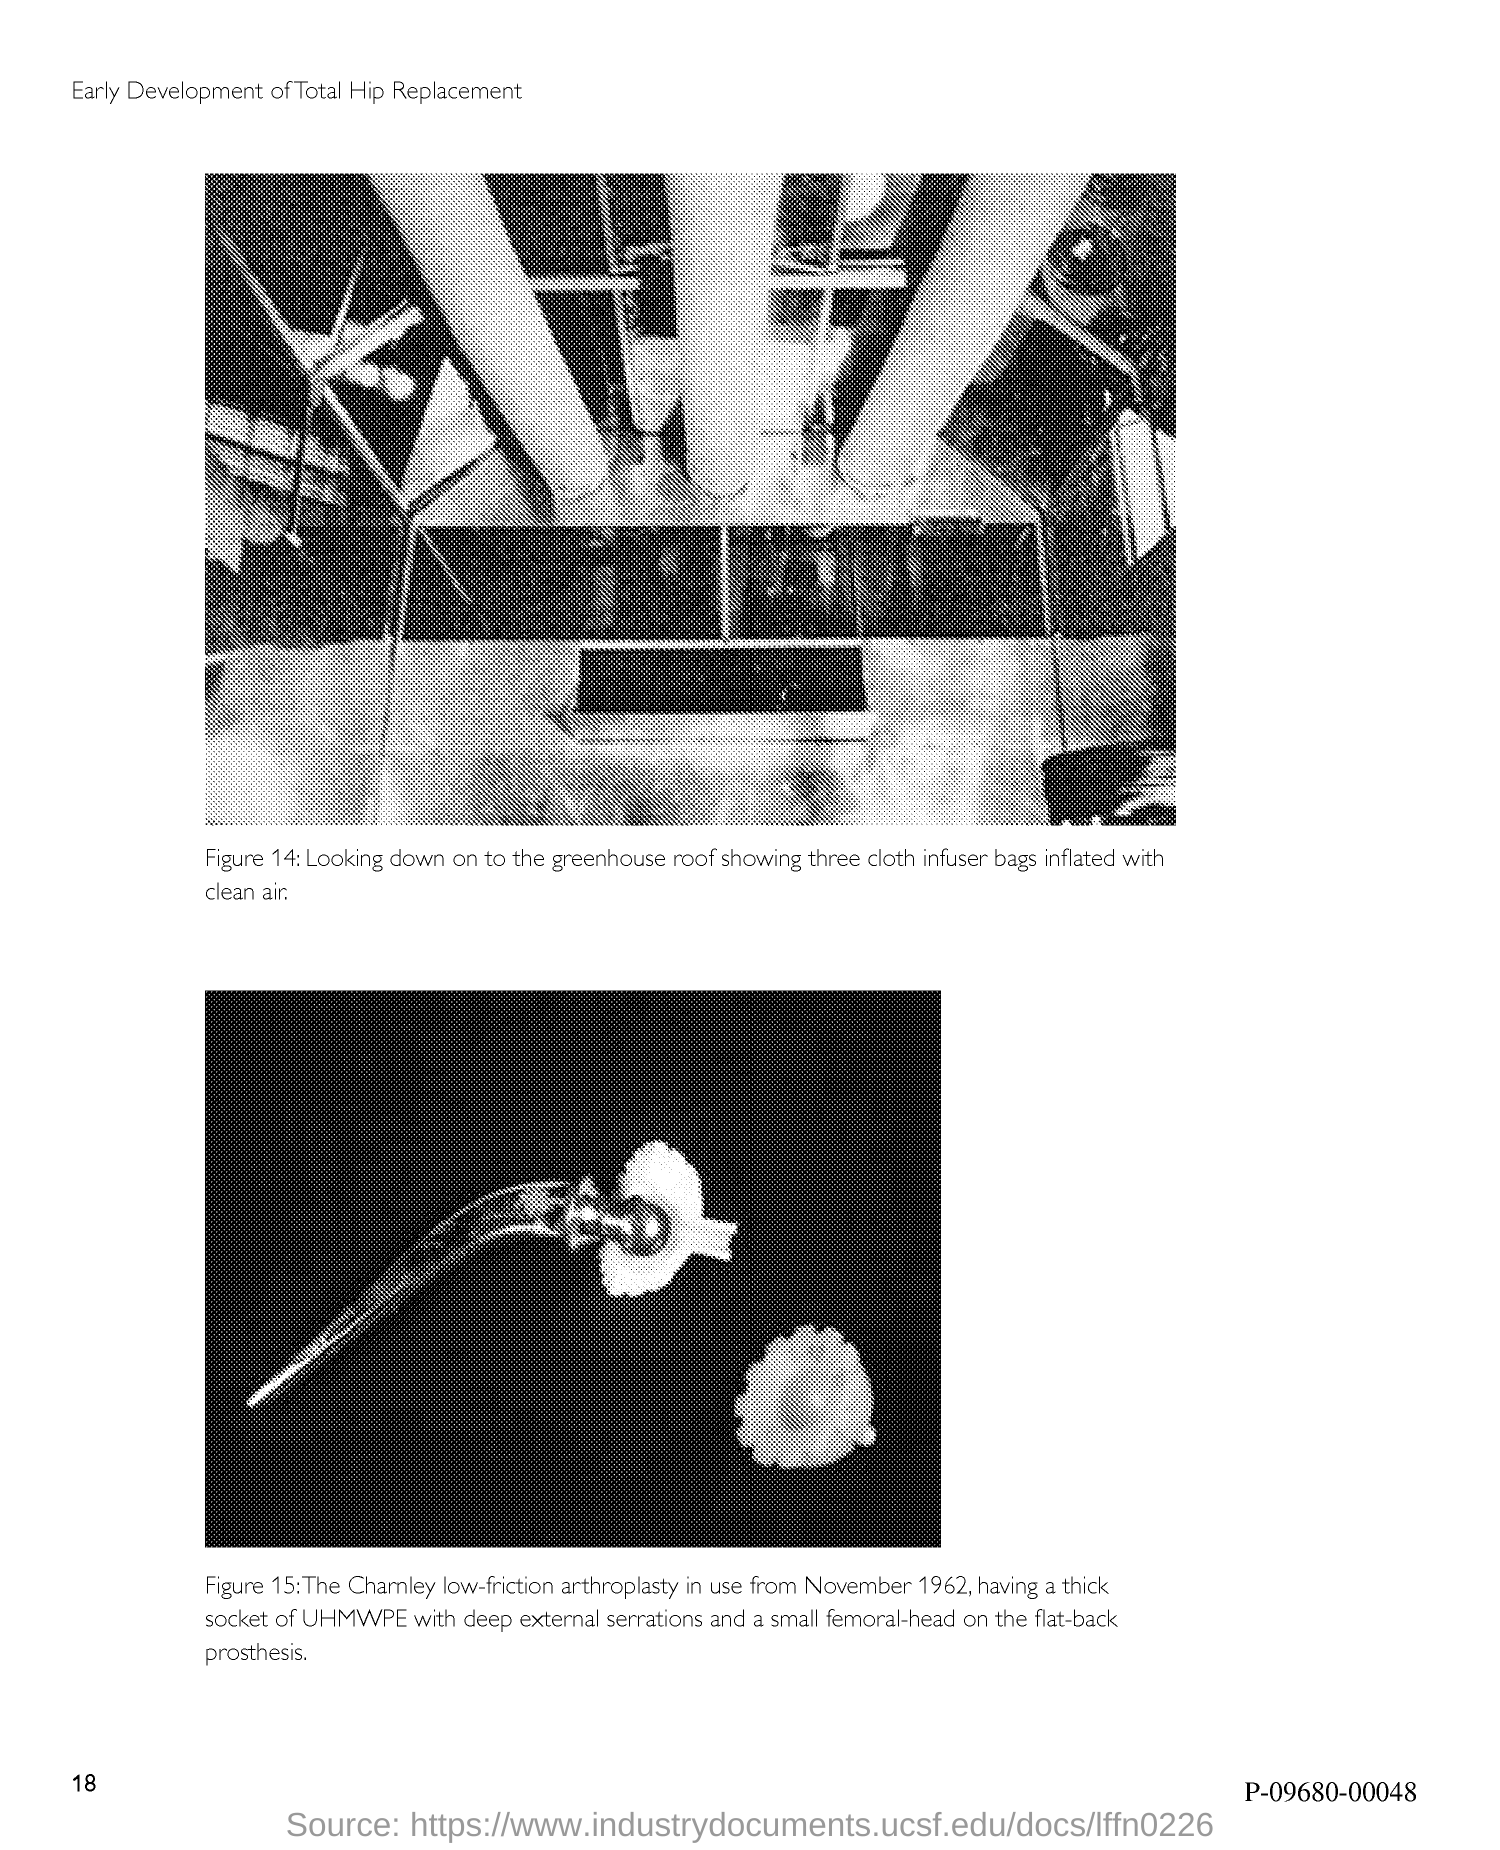Indicate a few pertinent items in this graphic. Figure 14 in the document depicts a view of the greenhouse roof from above, showcasing three inflated cloth infuser bags filled with clean air. The page number mentioned in this document is 18. 